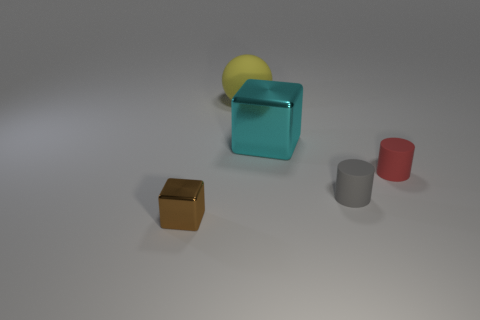Add 5 big yellow metallic things. How many objects exist? 10 Subtract all cylinders. How many objects are left? 3 Subtract 1 yellow spheres. How many objects are left? 4 Subtract all small things. Subtract all cylinders. How many objects are left? 0 Add 5 matte balls. How many matte balls are left? 6 Add 5 big blue spheres. How many big blue spheres exist? 5 